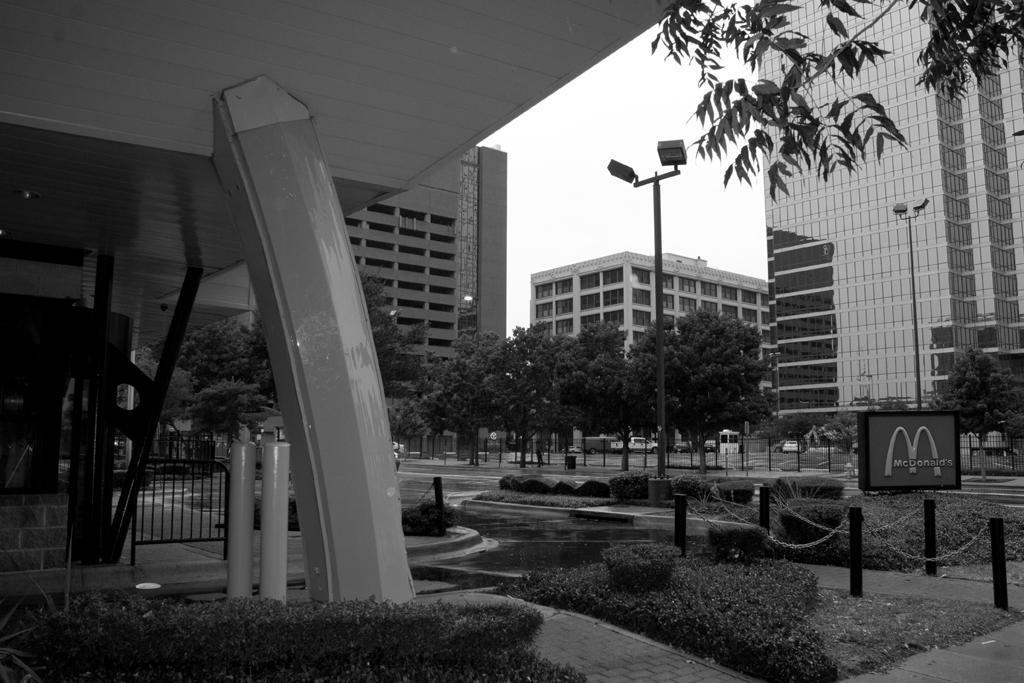What type of vegetation can be seen in the image? There are trees, grass, and plants in the image. What is the tall structure with a light on top in the image? There is a light pole in the image. What type of structures are visible in the image? There are buildings in the image. What else can be seen moving on the ground in the image? There are vehicles in the image. What part of the natural environment is visible in the image? The sky is visible in the image. What type of alley can be seen in the image? There is no alley present in the image. How does the town shake in the image? The image does not depict a town, and therefore there is no shaking occurring. 